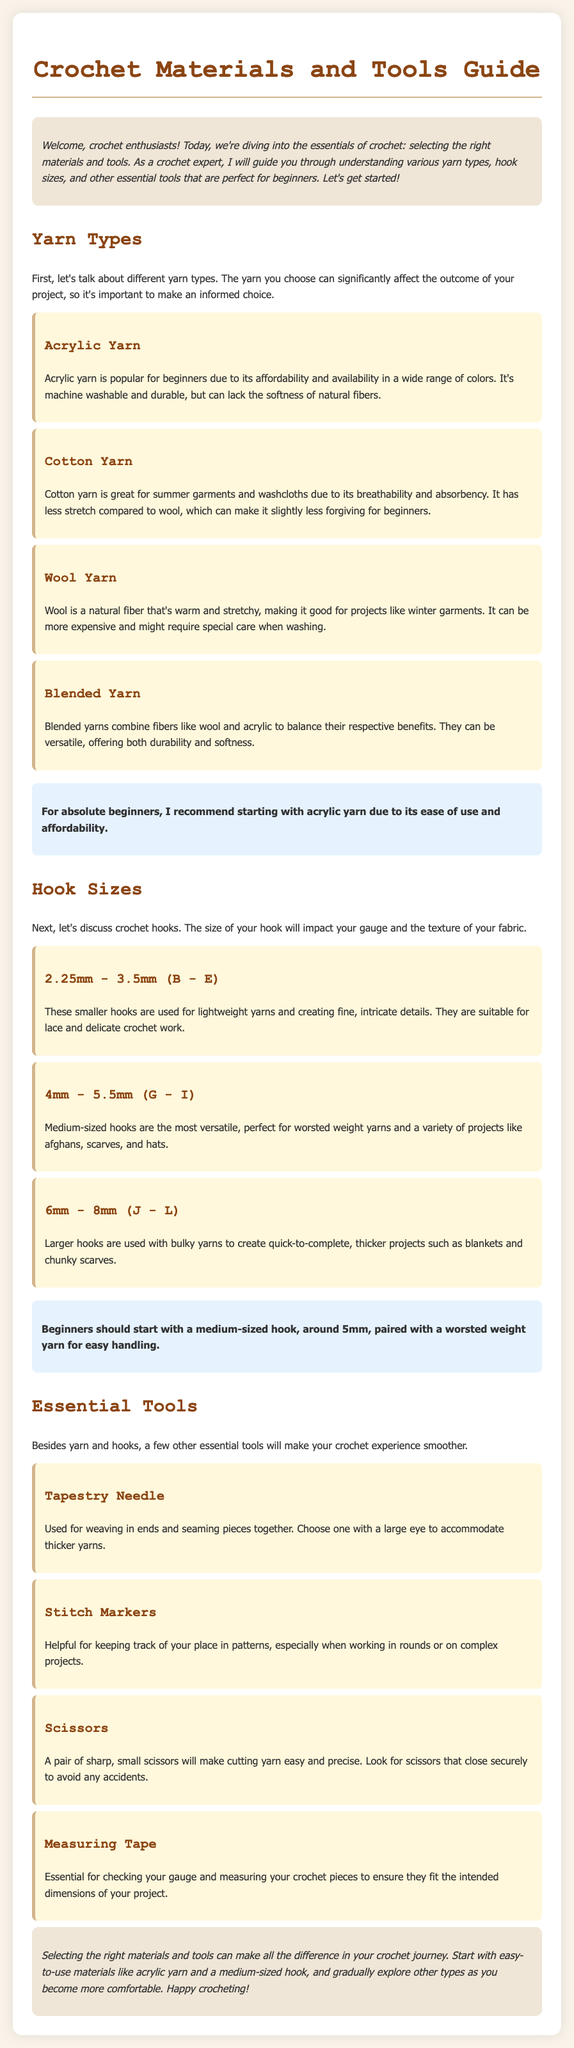What is the primary benefit of acrylic yarn? Acrylic yarn is popular for beginners due to its affordability and availability in a wide range of colors.
Answer: Affordability What hook size is recommended for beginners? The document suggests that beginners should start with a medium-sized hook, around 5mm, paired with a worsted weight yarn.
Answer: 5mm Which type of yarn is best for summer garments? The text indicates that cotton yarn is great for summer garments and washcloths due to its breathability and absorbency.
Answer: Cotton yarn What essential tool is used for weaving in ends? A tapestry needle is used for weaving in ends and seaming pieces together.
Answer: Tapestry needle What is the purpose of stitch markers? Stitch markers are helpful for keeping track of your place in patterns, especially when working in rounds or on complex projects.
Answer: Keeping track of place Which yarn type is considered less forgiving for beginners? Cotton yarn has less stretch compared to wool, which can make it slightly less forgiving for beginners.
Answer: Cotton yarn What is the characteristic of blended yarn? Blended yarns combine fibers like wool and acrylic to balance their respective benefits.
Answer: Versatile What should be checked using measuring tape? Measuring tape is essential for checking your gauge and measuring your crochet pieces to ensure they fit the intended dimensions of your project.
Answer: Gauge What is the conclusion about material selection in crochet? The conclusion emphasizes that selecting the right materials and tools can make all the difference in your crochet journey.
Answer: Important difference 